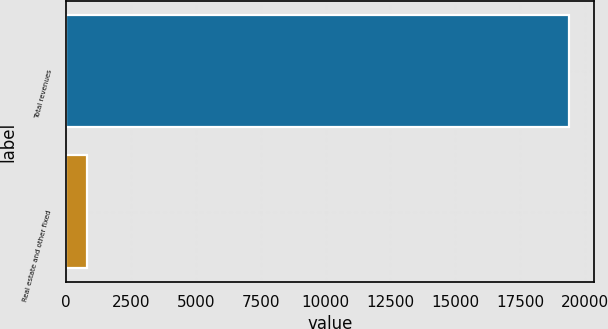<chart> <loc_0><loc_0><loc_500><loc_500><bar_chart><fcel>Total revenues<fcel>Real estate and other fixed<nl><fcel>19383<fcel>790<nl></chart> 